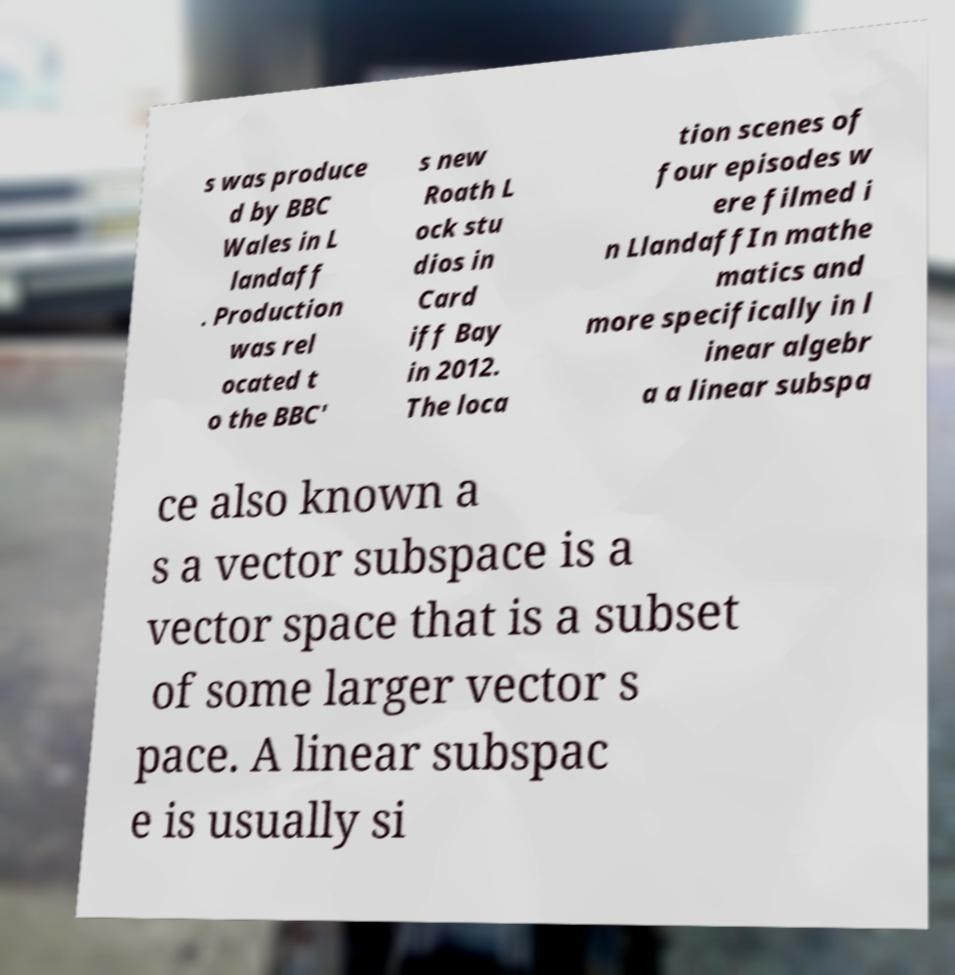Could you extract and type out the text from this image? s was produce d by BBC Wales in L landaff . Production was rel ocated t o the BBC' s new Roath L ock stu dios in Card iff Bay in 2012. The loca tion scenes of four episodes w ere filmed i n LlandaffIn mathe matics and more specifically in l inear algebr a a linear subspa ce also known a s a vector subspace is a vector space that is a subset of some larger vector s pace. A linear subspac e is usually si 